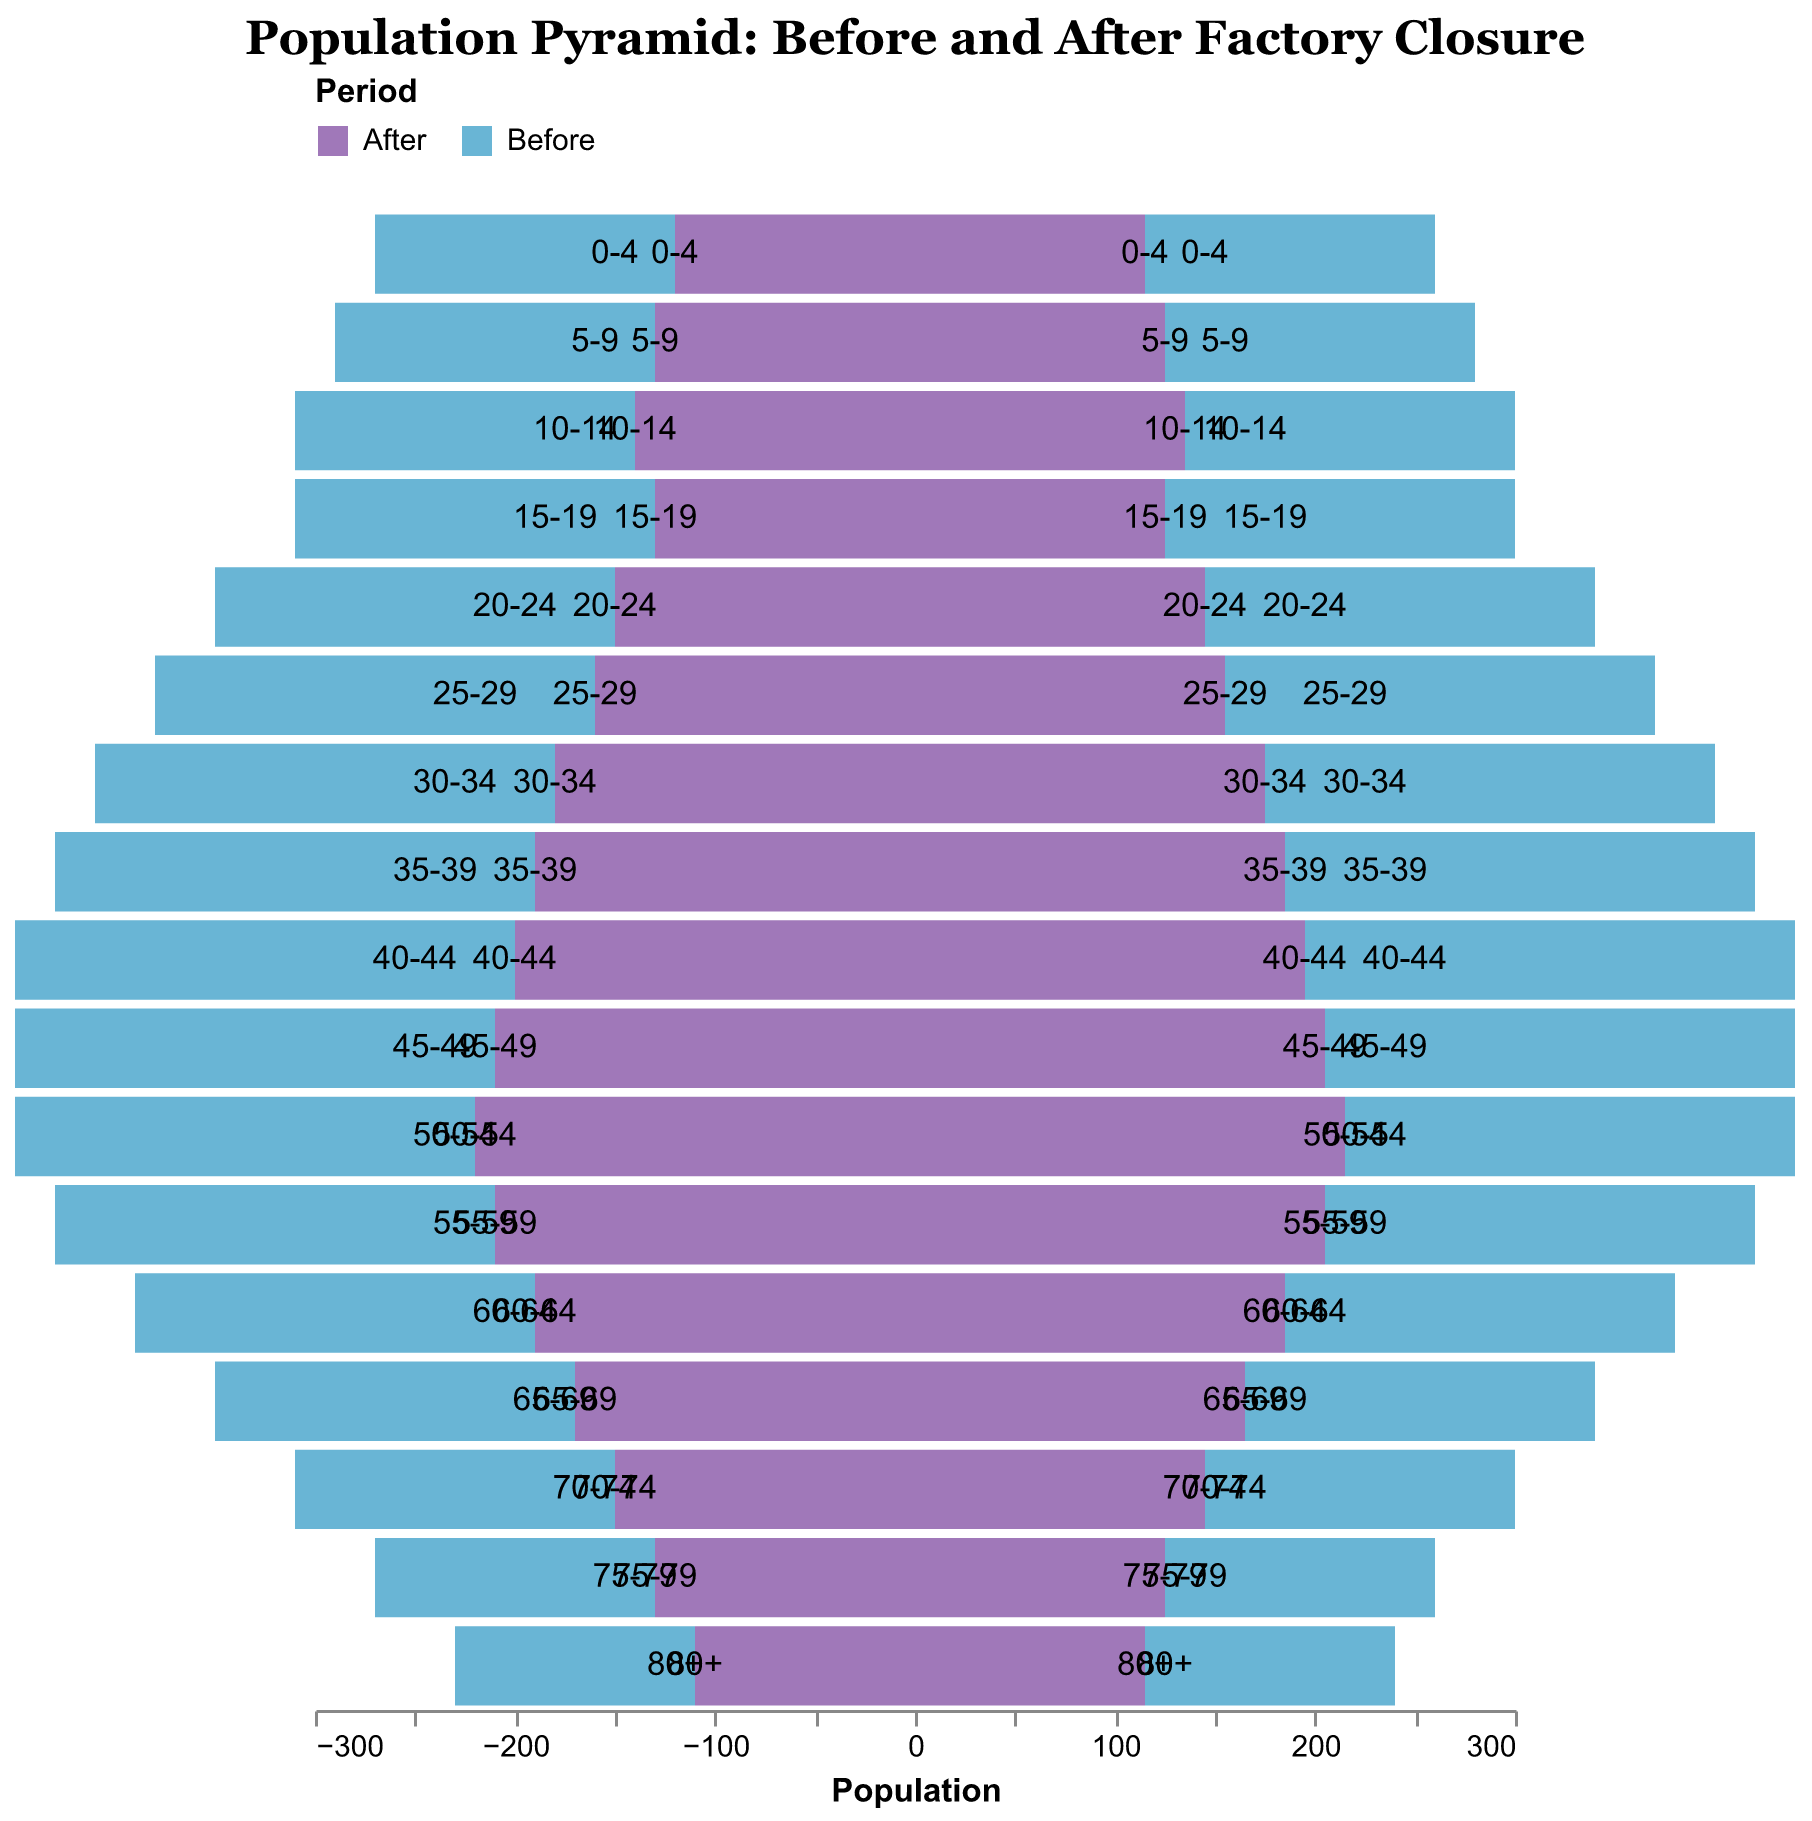What is the title of the population pyramid? The title is displayed at the top of the population pyramid, it is typically set in a larger and bold font to capture attention.
Answer: Population Pyramid: Before and After Factory Closure How many age groups are represented in the population pyramid? The age groups are listed on the y-axis of the pyramid. By counting the unique age groups shown, we can determine the total number.
Answer: 17 Which age group had the highest population of males before the factory closure? By analyzing the bars on the left side of the pyramid for the "before" period, find the age group with the longest bar.
Answer: 40-44 Did the population of females aged 50-54 increase or decrease after the factory closure? Compare the bar length for females aged 50-54 before and after the factory closure. If the bar is shorter, it decreased, otherwise, it increased.
Answer: Decrease Which gender and age group saw the largest decrease in population from before to after the factory closure? Identify the age group and gender with the largest difference in bar lengths by calculating the differences for each.
Answer: 40-44 Males What is the total population of all age groups combined for males before the factory closure? Sum the population values of all age groups for males before the factory closure.
Answer: 3410 How does the population of males aged 15-19 after the closure compare to males aged 30-34 after the closure? Compare the lengths of the bars representing these two age groups for males after the closure. One bar will be shorter, indicating a lower population.
Answer: Males aged 15-19 have a smaller population after closure By how much did the population of females aged 25-29 decrease after the factory closure? Subtract the "after" population value from the "before" population value for females aged 25-29.
Answer: 60 What period is represented by blue color in the pyramid? Refer to the color legend at the top of the pyramid. The color legend maps blue to a specific period.
Answer: After What age group showed the smallest change in population for both genders after the factory closure? Compare the differences in populations for all age groups and identify the age group with the smallest change for both males and females.
Answer: 55-59 